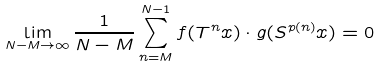<formula> <loc_0><loc_0><loc_500><loc_500>\lim _ { N - M \to \infty } \frac { 1 } { N - M } \sum _ { n = M } ^ { N - 1 } f ( T ^ { n } x ) \cdot g ( S ^ { p ( n ) } x ) = 0</formula> 